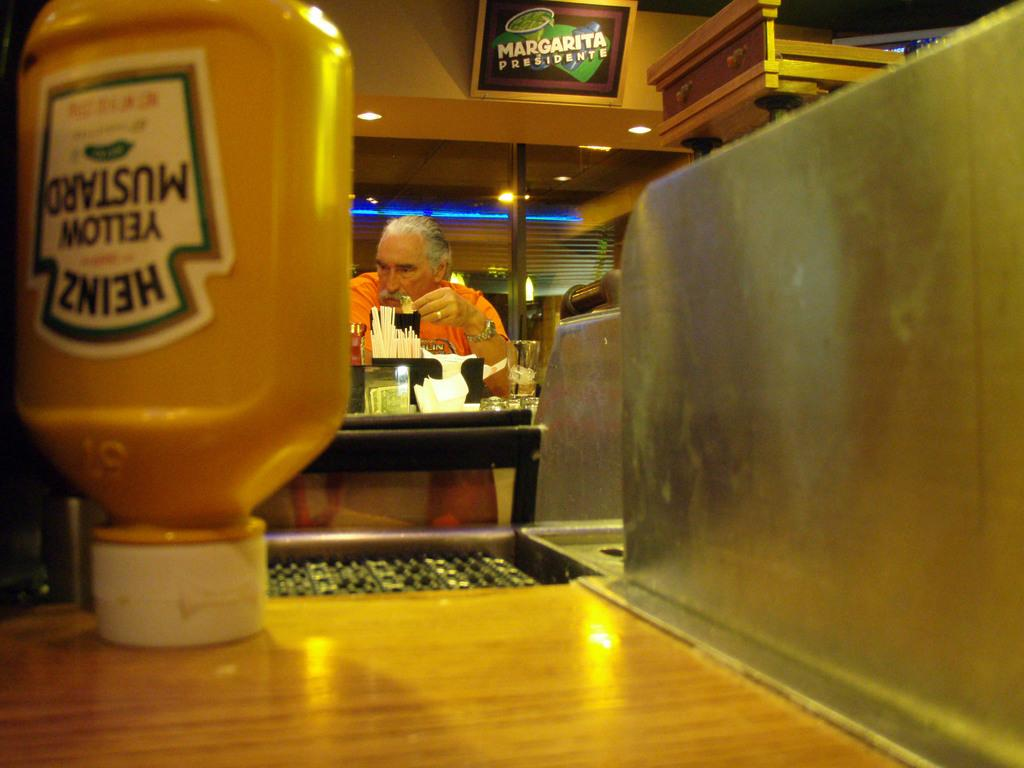<image>
Describe the image concisely. An upside down mustard bottle rests on the counter at a diner. 